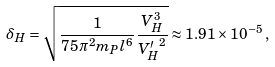Convert formula to latex. <formula><loc_0><loc_0><loc_500><loc_500>\delta _ { H } = \sqrt { \frac { 1 } { 7 5 \pi ^ { 2 } m _ { P } l ^ { 6 } } \frac { V _ { H } ^ { 3 } } { { V _ { H } ^ { \prime } } ^ { 2 } } } \approx 1 . 9 1 \times 1 0 ^ { - 5 } \, ,</formula> 